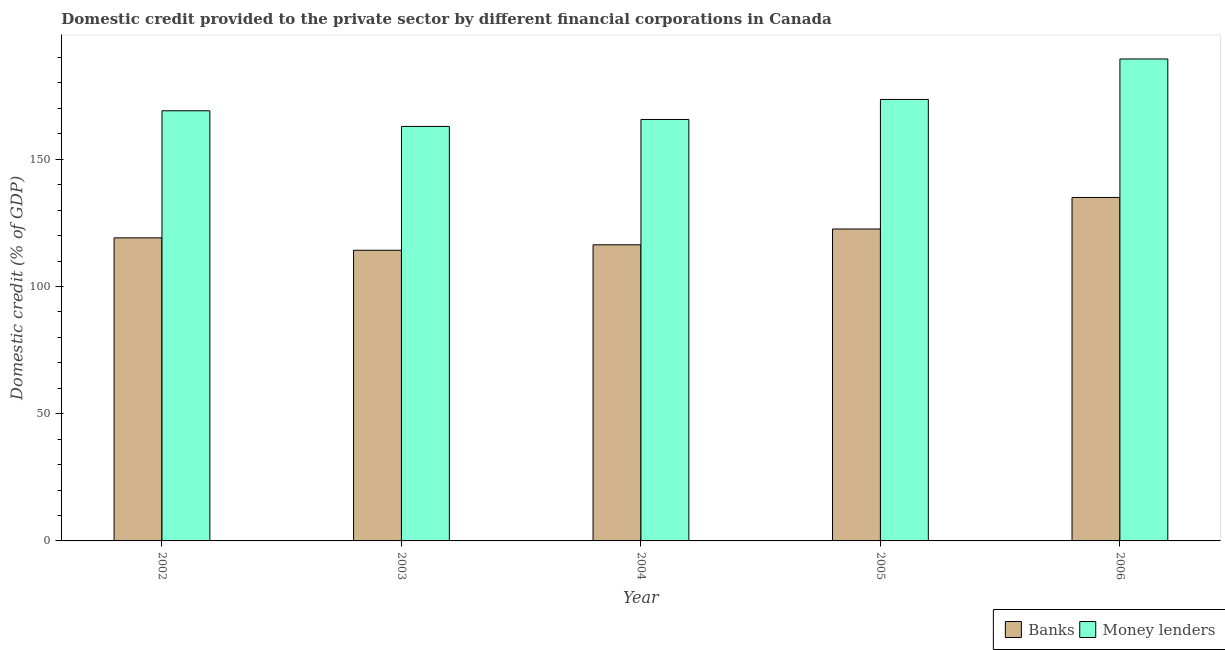Are the number of bars on each tick of the X-axis equal?
Ensure brevity in your answer.  Yes. How many bars are there on the 2nd tick from the left?
Keep it short and to the point. 2. What is the domestic credit provided by banks in 2002?
Your answer should be very brief. 119.11. Across all years, what is the maximum domestic credit provided by banks?
Ensure brevity in your answer.  134.99. Across all years, what is the minimum domestic credit provided by money lenders?
Your answer should be compact. 162.91. In which year was the domestic credit provided by money lenders maximum?
Your answer should be compact. 2006. In which year was the domestic credit provided by banks minimum?
Provide a short and direct response. 2003. What is the total domestic credit provided by banks in the graph?
Provide a short and direct response. 607.32. What is the difference between the domestic credit provided by money lenders in 2004 and that in 2006?
Your answer should be compact. -23.77. What is the difference between the domestic credit provided by money lenders in 2003 and the domestic credit provided by banks in 2002?
Provide a short and direct response. -6.15. What is the average domestic credit provided by money lenders per year?
Offer a very short reply. 172.11. In the year 2004, what is the difference between the domestic credit provided by money lenders and domestic credit provided by banks?
Give a very brief answer. 0. In how many years, is the domestic credit provided by money lenders greater than 150 %?
Provide a short and direct response. 5. What is the ratio of the domestic credit provided by banks in 2004 to that in 2005?
Provide a succinct answer. 0.95. Is the domestic credit provided by banks in 2002 less than that in 2004?
Your answer should be very brief. No. Is the difference between the domestic credit provided by money lenders in 2004 and 2006 greater than the difference between the domestic credit provided by banks in 2004 and 2006?
Offer a very short reply. No. What is the difference between the highest and the second highest domestic credit provided by banks?
Your answer should be very brief. 12.39. What is the difference between the highest and the lowest domestic credit provided by money lenders?
Your answer should be compact. 26.51. In how many years, is the domestic credit provided by money lenders greater than the average domestic credit provided by money lenders taken over all years?
Your response must be concise. 2. What does the 2nd bar from the left in 2005 represents?
Offer a very short reply. Money lenders. What does the 1st bar from the right in 2006 represents?
Provide a succinct answer. Money lenders. What is the difference between two consecutive major ticks on the Y-axis?
Give a very brief answer. 50. Are the values on the major ticks of Y-axis written in scientific E-notation?
Make the answer very short. No. Does the graph contain grids?
Offer a very short reply. No. How many legend labels are there?
Your response must be concise. 2. How are the legend labels stacked?
Provide a short and direct response. Horizontal. What is the title of the graph?
Offer a very short reply. Domestic credit provided to the private sector by different financial corporations in Canada. Does "Unregistered firms" appear as one of the legend labels in the graph?
Keep it short and to the point. No. What is the label or title of the X-axis?
Make the answer very short. Year. What is the label or title of the Y-axis?
Offer a very short reply. Domestic credit (% of GDP). What is the Domestic credit (% of GDP) in Banks in 2002?
Make the answer very short. 119.11. What is the Domestic credit (% of GDP) of Money lenders in 2002?
Ensure brevity in your answer.  169.06. What is the Domestic credit (% of GDP) in Banks in 2003?
Provide a short and direct response. 114.23. What is the Domestic credit (% of GDP) of Money lenders in 2003?
Provide a succinct answer. 162.91. What is the Domestic credit (% of GDP) of Banks in 2004?
Your answer should be very brief. 116.38. What is the Domestic credit (% of GDP) in Money lenders in 2004?
Your response must be concise. 165.65. What is the Domestic credit (% of GDP) in Banks in 2005?
Give a very brief answer. 122.6. What is the Domestic credit (% of GDP) in Money lenders in 2005?
Offer a very short reply. 173.52. What is the Domestic credit (% of GDP) of Banks in 2006?
Make the answer very short. 134.99. What is the Domestic credit (% of GDP) in Money lenders in 2006?
Provide a short and direct response. 189.43. Across all years, what is the maximum Domestic credit (% of GDP) in Banks?
Keep it short and to the point. 134.99. Across all years, what is the maximum Domestic credit (% of GDP) of Money lenders?
Keep it short and to the point. 189.43. Across all years, what is the minimum Domestic credit (% of GDP) in Banks?
Provide a succinct answer. 114.23. Across all years, what is the minimum Domestic credit (% of GDP) in Money lenders?
Offer a terse response. 162.91. What is the total Domestic credit (% of GDP) of Banks in the graph?
Provide a succinct answer. 607.32. What is the total Domestic credit (% of GDP) of Money lenders in the graph?
Provide a short and direct response. 860.57. What is the difference between the Domestic credit (% of GDP) of Banks in 2002 and that in 2003?
Offer a very short reply. 4.88. What is the difference between the Domestic credit (% of GDP) in Money lenders in 2002 and that in 2003?
Make the answer very short. 6.15. What is the difference between the Domestic credit (% of GDP) in Banks in 2002 and that in 2004?
Keep it short and to the point. 2.73. What is the difference between the Domestic credit (% of GDP) in Money lenders in 2002 and that in 2004?
Provide a short and direct response. 3.41. What is the difference between the Domestic credit (% of GDP) of Banks in 2002 and that in 2005?
Keep it short and to the point. -3.49. What is the difference between the Domestic credit (% of GDP) of Money lenders in 2002 and that in 2005?
Offer a very short reply. -4.45. What is the difference between the Domestic credit (% of GDP) in Banks in 2002 and that in 2006?
Offer a terse response. -15.88. What is the difference between the Domestic credit (% of GDP) of Money lenders in 2002 and that in 2006?
Your answer should be very brief. -20.36. What is the difference between the Domestic credit (% of GDP) of Banks in 2003 and that in 2004?
Your response must be concise. -2.15. What is the difference between the Domestic credit (% of GDP) in Money lenders in 2003 and that in 2004?
Offer a very short reply. -2.74. What is the difference between the Domestic credit (% of GDP) in Banks in 2003 and that in 2005?
Your answer should be very brief. -8.36. What is the difference between the Domestic credit (% of GDP) in Money lenders in 2003 and that in 2005?
Your answer should be compact. -10.6. What is the difference between the Domestic credit (% of GDP) in Banks in 2003 and that in 2006?
Your answer should be compact. -20.76. What is the difference between the Domestic credit (% of GDP) in Money lenders in 2003 and that in 2006?
Offer a very short reply. -26.51. What is the difference between the Domestic credit (% of GDP) in Banks in 2004 and that in 2005?
Your response must be concise. -6.21. What is the difference between the Domestic credit (% of GDP) of Money lenders in 2004 and that in 2005?
Your response must be concise. -7.87. What is the difference between the Domestic credit (% of GDP) of Banks in 2004 and that in 2006?
Give a very brief answer. -18.61. What is the difference between the Domestic credit (% of GDP) in Money lenders in 2004 and that in 2006?
Provide a succinct answer. -23.77. What is the difference between the Domestic credit (% of GDP) in Banks in 2005 and that in 2006?
Ensure brevity in your answer.  -12.39. What is the difference between the Domestic credit (% of GDP) in Money lenders in 2005 and that in 2006?
Give a very brief answer. -15.91. What is the difference between the Domestic credit (% of GDP) in Banks in 2002 and the Domestic credit (% of GDP) in Money lenders in 2003?
Give a very brief answer. -43.8. What is the difference between the Domestic credit (% of GDP) of Banks in 2002 and the Domestic credit (% of GDP) of Money lenders in 2004?
Keep it short and to the point. -46.54. What is the difference between the Domestic credit (% of GDP) in Banks in 2002 and the Domestic credit (% of GDP) in Money lenders in 2005?
Your response must be concise. -54.41. What is the difference between the Domestic credit (% of GDP) of Banks in 2002 and the Domestic credit (% of GDP) of Money lenders in 2006?
Provide a short and direct response. -70.31. What is the difference between the Domestic credit (% of GDP) of Banks in 2003 and the Domestic credit (% of GDP) of Money lenders in 2004?
Make the answer very short. -51.42. What is the difference between the Domestic credit (% of GDP) of Banks in 2003 and the Domestic credit (% of GDP) of Money lenders in 2005?
Give a very brief answer. -59.28. What is the difference between the Domestic credit (% of GDP) of Banks in 2003 and the Domestic credit (% of GDP) of Money lenders in 2006?
Your answer should be very brief. -75.19. What is the difference between the Domestic credit (% of GDP) in Banks in 2004 and the Domestic credit (% of GDP) in Money lenders in 2005?
Provide a short and direct response. -57.14. What is the difference between the Domestic credit (% of GDP) of Banks in 2004 and the Domestic credit (% of GDP) of Money lenders in 2006?
Offer a terse response. -73.04. What is the difference between the Domestic credit (% of GDP) of Banks in 2005 and the Domestic credit (% of GDP) of Money lenders in 2006?
Make the answer very short. -66.83. What is the average Domestic credit (% of GDP) in Banks per year?
Offer a terse response. 121.46. What is the average Domestic credit (% of GDP) in Money lenders per year?
Ensure brevity in your answer.  172.11. In the year 2002, what is the difference between the Domestic credit (% of GDP) in Banks and Domestic credit (% of GDP) in Money lenders?
Your answer should be compact. -49.95. In the year 2003, what is the difference between the Domestic credit (% of GDP) of Banks and Domestic credit (% of GDP) of Money lenders?
Offer a very short reply. -48.68. In the year 2004, what is the difference between the Domestic credit (% of GDP) of Banks and Domestic credit (% of GDP) of Money lenders?
Provide a short and direct response. -49.27. In the year 2005, what is the difference between the Domestic credit (% of GDP) of Banks and Domestic credit (% of GDP) of Money lenders?
Keep it short and to the point. -50.92. In the year 2006, what is the difference between the Domestic credit (% of GDP) of Banks and Domestic credit (% of GDP) of Money lenders?
Keep it short and to the point. -54.43. What is the ratio of the Domestic credit (% of GDP) in Banks in 2002 to that in 2003?
Provide a succinct answer. 1.04. What is the ratio of the Domestic credit (% of GDP) of Money lenders in 2002 to that in 2003?
Give a very brief answer. 1.04. What is the ratio of the Domestic credit (% of GDP) of Banks in 2002 to that in 2004?
Your answer should be compact. 1.02. What is the ratio of the Domestic credit (% of GDP) of Money lenders in 2002 to that in 2004?
Your response must be concise. 1.02. What is the ratio of the Domestic credit (% of GDP) in Banks in 2002 to that in 2005?
Provide a short and direct response. 0.97. What is the ratio of the Domestic credit (% of GDP) of Money lenders in 2002 to that in 2005?
Offer a very short reply. 0.97. What is the ratio of the Domestic credit (% of GDP) in Banks in 2002 to that in 2006?
Your response must be concise. 0.88. What is the ratio of the Domestic credit (% of GDP) in Money lenders in 2002 to that in 2006?
Your answer should be compact. 0.89. What is the ratio of the Domestic credit (% of GDP) of Banks in 2003 to that in 2004?
Offer a terse response. 0.98. What is the ratio of the Domestic credit (% of GDP) of Money lenders in 2003 to that in 2004?
Your answer should be very brief. 0.98. What is the ratio of the Domestic credit (% of GDP) of Banks in 2003 to that in 2005?
Offer a very short reply. 0.93. What is the ratio of the Domestic credit (% of GDP) in Money lenders in 2003 to that in 2005?
Offer a very short reply. 0.94. What is the ratio of the Domestic credit (% of GDP) in Banks in 2003 to that in 2006?
Provide a short and direct response. 0.85. What is the ratio of the Domestic credit (% of GDP) of Money lenders in 2003 to that in 2006?
Keep it short and to the point. 0.86. What is the ratio of the Domestic credit (% of GDP) of Banks in 2004 to that in 2005?
Make the answer very short. 0.95. What is the ratio of the Domestic credit (% of GDP) in Money lenders in 2004 to that in 2005?
Your answer should be compact. 0.95. What is the ratio of the Domestic credit (% of GDP) of Banks in 2004 to that in 2006?
Your answer should be compact. 0.86. What is the ratio of the Domestic credit (% of GDP) of Money lenders in 2004 to that in 2006?
Keep it short and to the point. 0.87. What is the ratio of the Domestic credit (% of GDP) in Banks in 2005 to that in 2006?
Offer a very short reply. 0.91. What is the ratio of the Domestic credit (% of GDP) of Money lenders in 2005 to that in 2006?
Provide a short and direct response. 0.92. What is the difference between the highest and the second highest Domestic credit (% of GDP) in Banks?
Provide a succinct answer. 12.39. What is the difference between the highest and the second highest Domestic credit (% of GDP) in Money lenders?
Provide a succinct answer. 15.91. What is the difference between the highest and the lowest Domestic credit (% of GDP) of Banks?
Provide a short and direct response. 20.76. What is the difference between the highest and the lowest Domestic credit (% of GDP) of Money lenders?
Your answer should be very brief. 26.51. 